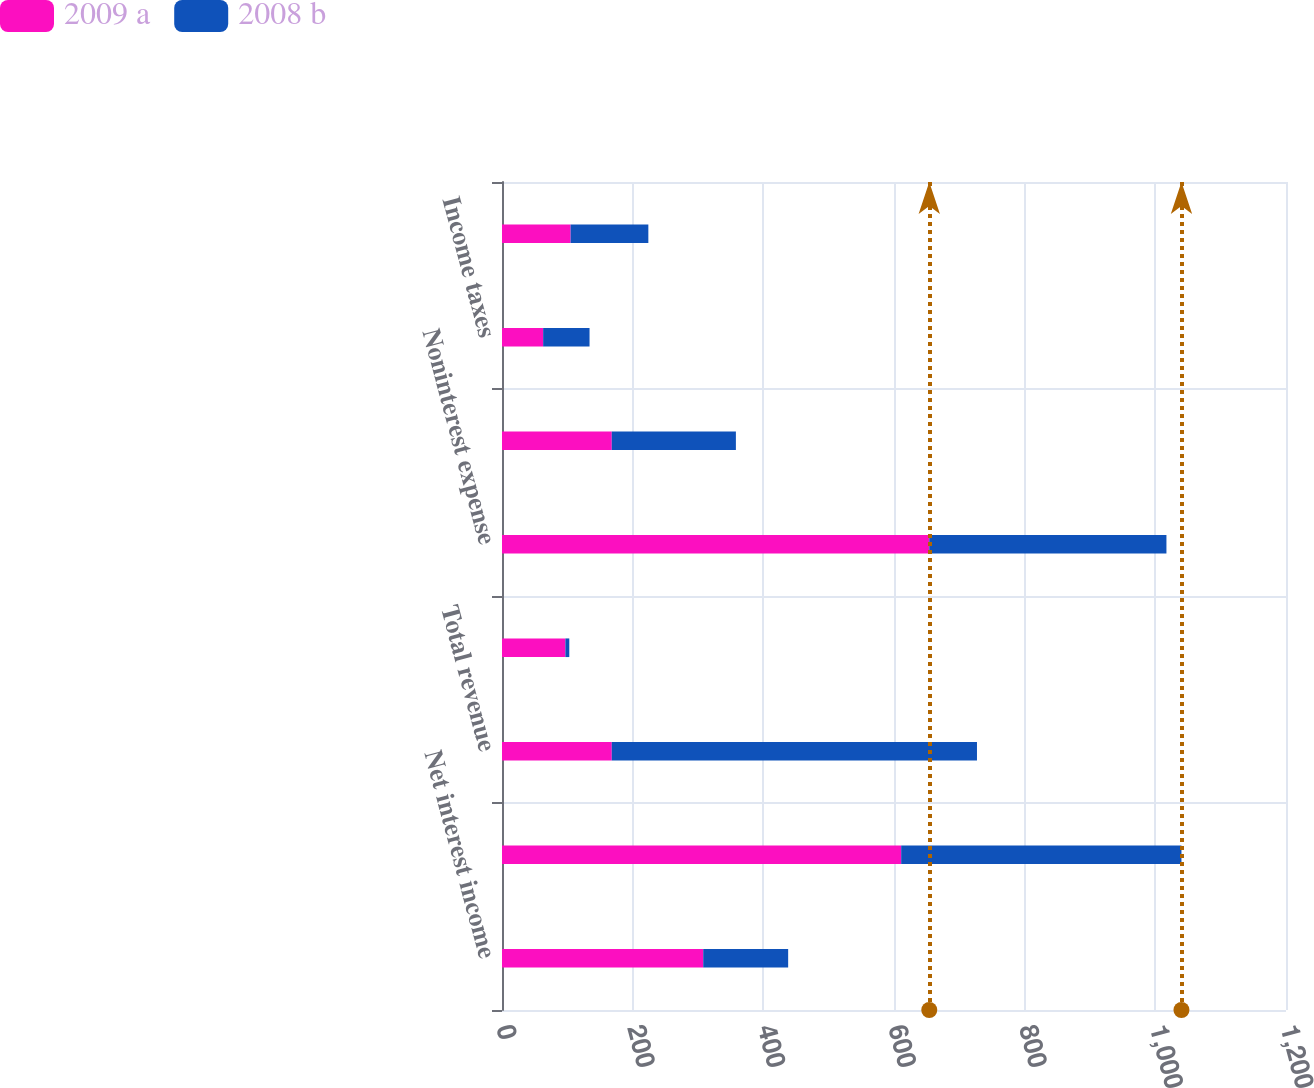Convert chart to OTSL. <chart><loc_0><loc_0><loc_500><loc_500><stacked_bar_chart><ecel><fcel>Net interest income<fcel>Noninterest income<fcel>Total revenue<fcel>Provision for credit losses<fcel>Noninterest expense<fcel>Pretax earnings<fcel>Income taxes<fcel>Earnings<nl><fcel>2009 a<fcel>308<fcel>611<fcel>168<fcel>97<fcel>654<fcel>168<fcel>63<fcel>105<nl><fcel>2008 b<fcel>130<fcel>429<fcel>559<fcel>6<fcel>363<fcel>190<fcel>71<fcel>119<nl></chart> 